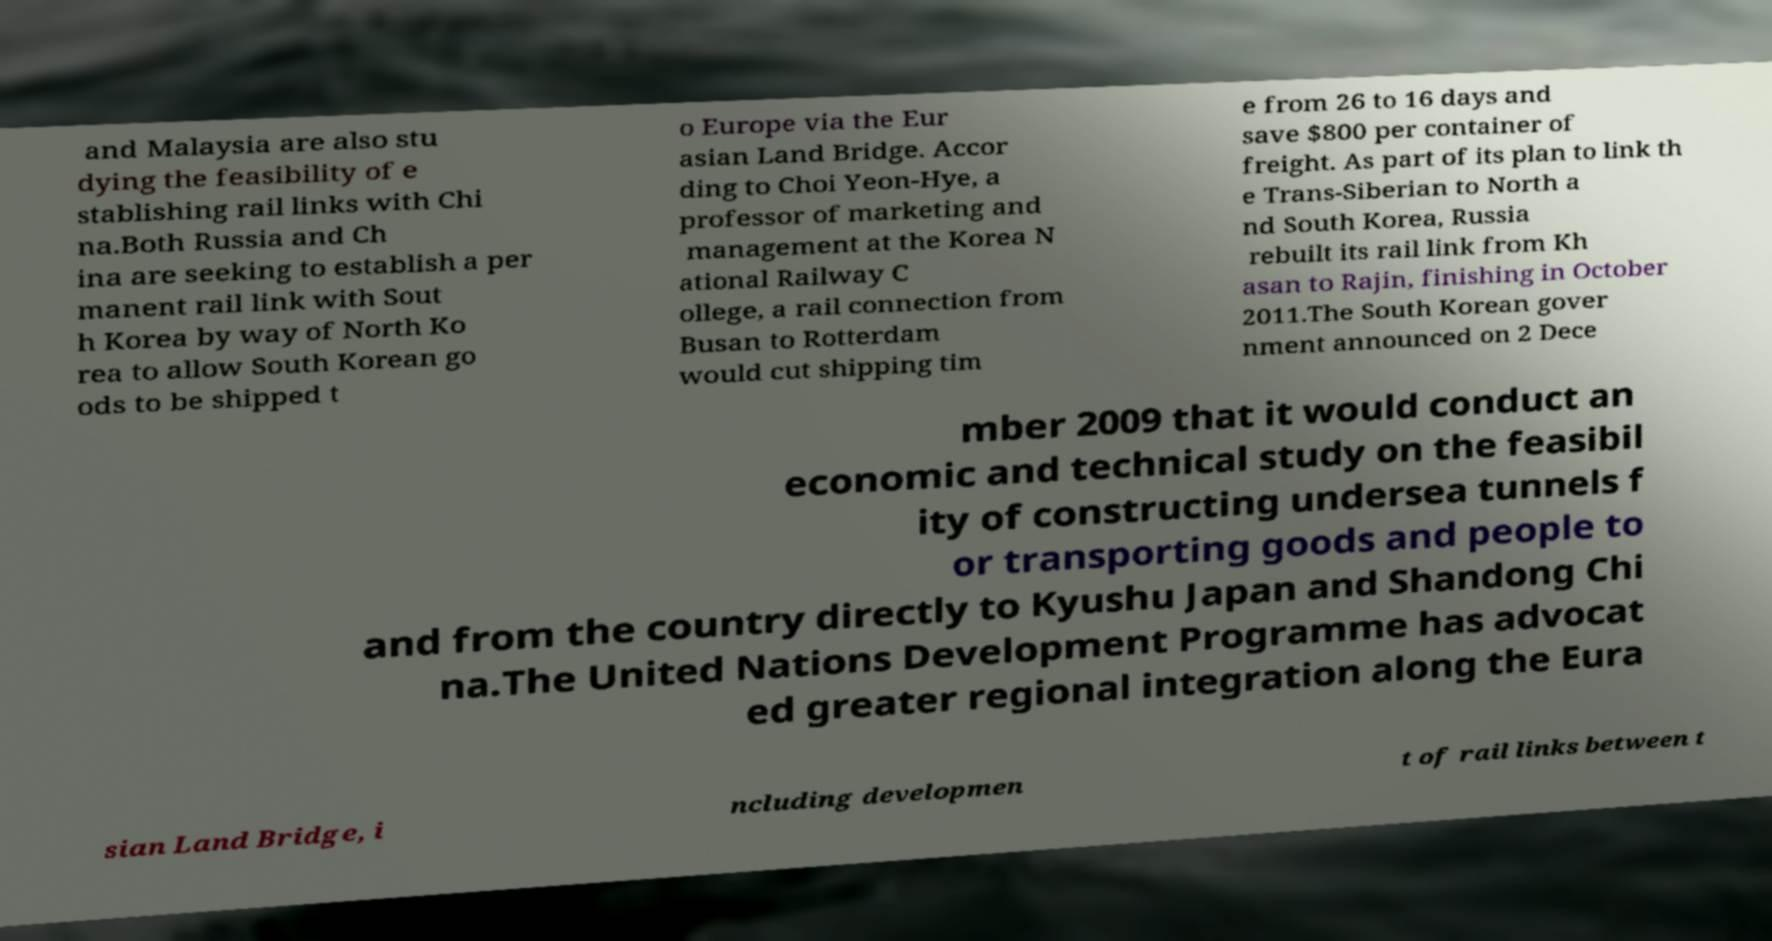What messages or text are displayed in this image? I need them in a readable, typed format. and Malaysia are also stu dying the feasibility of e stablishing rail links with Chi na.Both Russia and Ch ina are seeking to establish a per manent rail link with Sout h Korea by way of North Ko rea to allow South Korean go ods to be shipped t o Europe via the Eur asian Land Bridge. Accor ding to Choi Yeon-Hye, a professor of marketing and management at the Korea N ational Railway C ollege, a rail connection from Busan to Rotterdam would cut shipping tim e from 26 to 16 days and save $800 per container of freight. As part of its plan to link th e Trans-Siberian to North a nd South Korea, Russia rebuilt its rail link from Kh asan to Rajin, finishing in October 2011.The South Korean gover nment announced on 2 Dece mber 2009 that it would conduct an economic and technical study on the feasibil ity of constructing undersea tunnels f or transporting goods and people to and from the country directly to Kyushu Japan and Shandong Chi na.The United Nations Development Programme has advocat ed greater regional integration along the Eura sian Land Bridge, i ncluding developmen t of rail links between t 